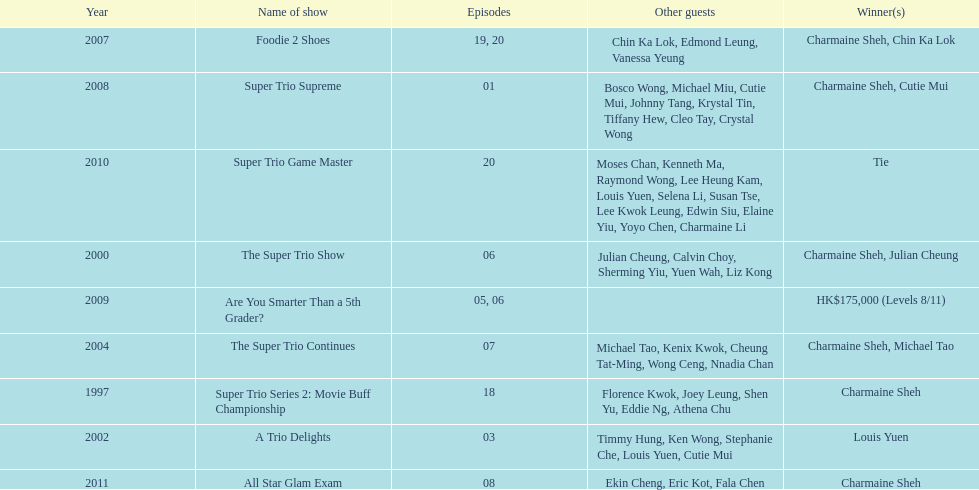How many times has charmaine sheh won on a variety show? 6. 